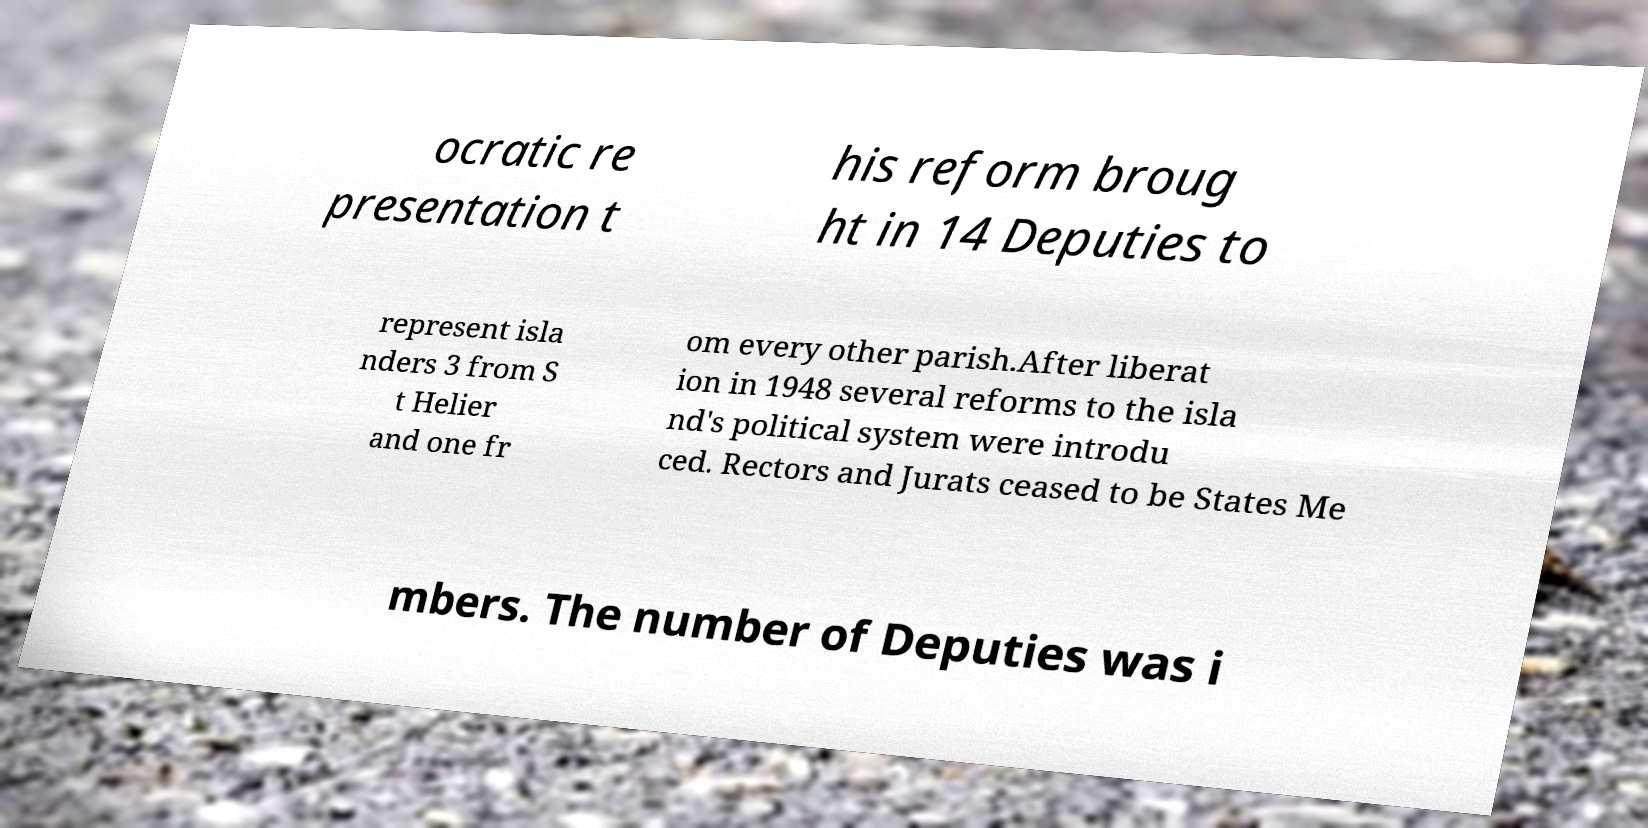What messages or text are displayed in this image? I need them in a readable, typed format. ocratic re presentation t his reform broug ht in 14 Deputies to represent isla nders 3 from S t Helier and one fr om every other parish.After liberat ion in 1948 several reforms to the isla nd's political system were introdu ced. Rectors and Jurats ceased to be States Me mbers. The number of Deputies was i 